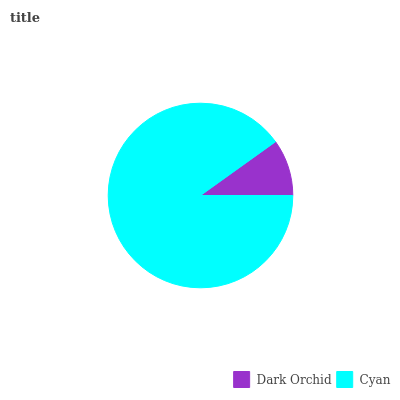Is Dark Orchid the minimum?
Answer yes or no. Yes. Is Cyan the maximum?
Answer yes or no. Yes. Is Cyan the minimum?
Answer yes or no. No. Is Cyan greater than Dark Orchid?
Answer yes or no. Yes. Is Dark Orchid less than Cyan?
Answer yes or no. Yes. Is Dark Orchid greater than Cyan?
Answer yes or no. No. Is Cyan less than Dark Orchid?
Answer yes or no. No. Is Cyan the high median?
Answer yes or no. Yes. Is Dark Orchid the low median?
Answer yes or no. Yes. Is Dark Orchid the high median?
Answer yes or no. No. Is Cyan the low median?
Answer yes or no. No. 